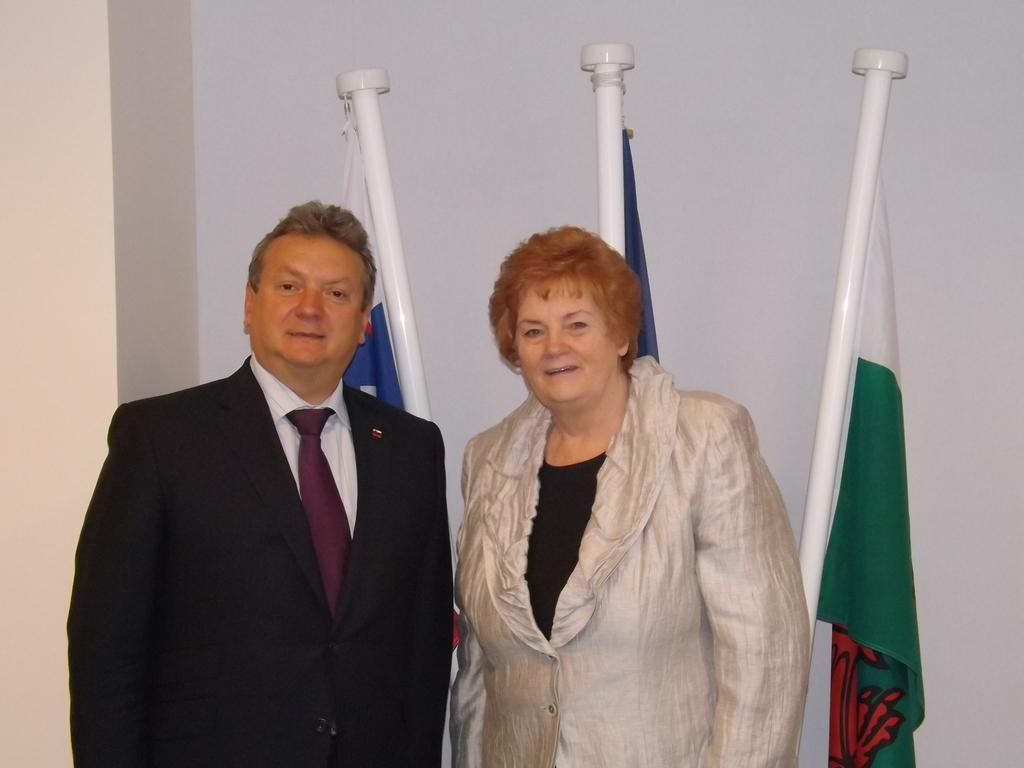How many people are present in the image? There are two people, a man and a woman, present in the image. What are the man and woman doing in the image? The man and woman are standing in the image. What can be seen in the background of the image? There are flags and a wall in the background of the image. What type of juice is being served at the low table in the image? There is no table, low or otherwise, present in the image, nor is there any juice visible. 